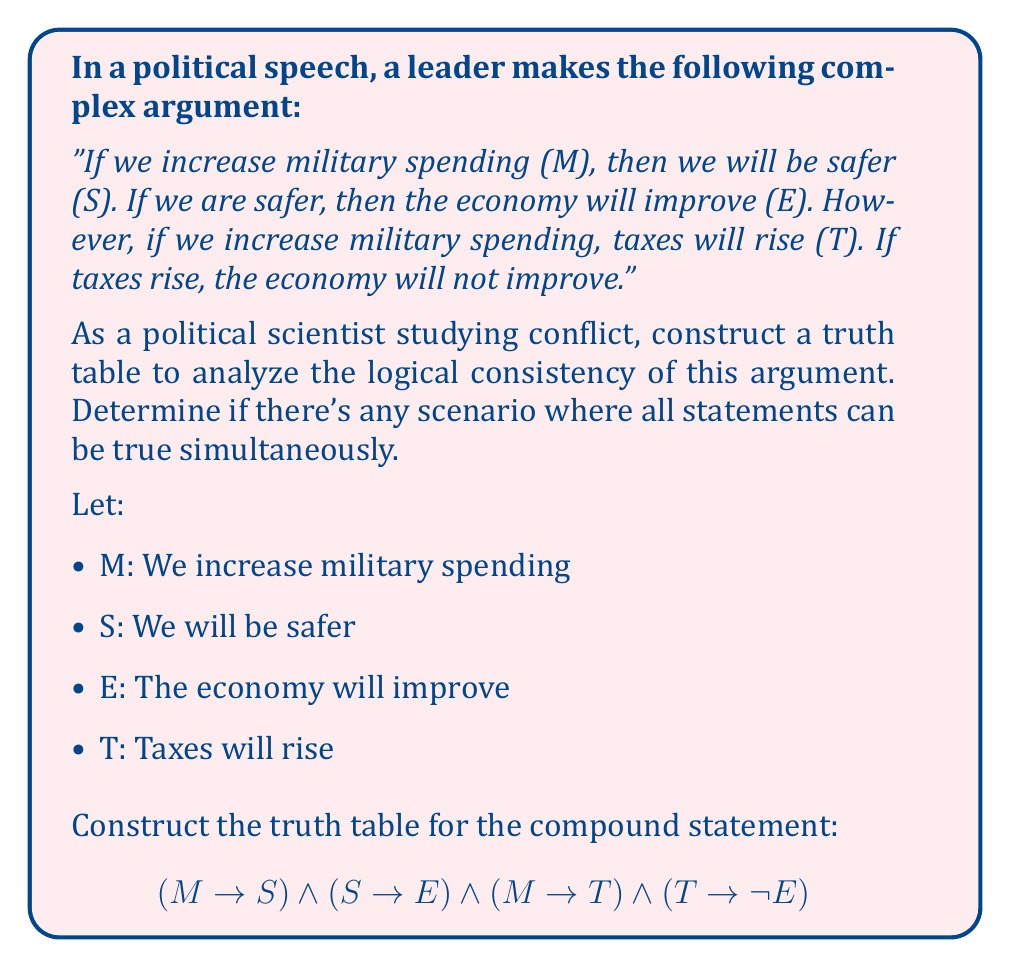Help me with this question. To analyze this argument, we'll construct a truth table for the given compound statement. We'll evaluate each component and then combine them to see if there's any row where all statements are true simultaneously.

1. First, let's list all possible combinations of truth values for M, S, T, and E:

   M | S | T | E
   ---------------
   T | T | T | T
   T | T | T | F
   T | T | F | T
   T | T | F | F
   T | F | T | T
   T | F | T | F
   T | F | F | T
   T | F | F | F
   F | T | T | T
   F | T | T | F
   F | T | F | T
   F | T | F | F
   F | F | T | T
   F | F | T | F
   F | F | F | T
   F | F | F | F

2. Now, let's evaluate each component of the compound statement:

   a) $M \rightarrow S$
   b) $S \rightarrow E$
   c) $M \rightarrow T$
   d) $T \rightarrow \lnot E$

3. Evaluate each component and the final compound statement:

   M | S | T | E | M→S | S→E | M→T | T→¬E | (M→S)∧(S→E)∧(M→T)∧(T→¬E)
   ----------------------------------------------------------------
   T | T | T | T |  T  |  T  |  T  |  F   |           F
   T | T | T | F |  T  |  F  |  T  |  T   |           F
   T | T | F | T |  T  |  T  |  F  |  T   |           F
   T | T | F | F |  T  |  F  |  F  |  T   |           F
   T | F | T | T |  F  |  T  |  T  |  F   |           F
   T | F | T | F |  F  |  T  |  T  |  T   |           F
   T | F | F | T |  F  |  T  |  F  |  T   |           F
   T | F | F | F |  F  |  T  |  F  |  T   |           F
   F | T | T | T |  T  |  T  |  T  |  F   |           F
   F | T | T | F |  T  |  F  |  T  |  T   |           F
   F | T | F | T |  T  |  T  |  T  |  T   |           T
   F | T | F | F |  T  |  F  |  T  |  T   |           F
   F | F | T | T |  T  |  T  |  T  |  F   |           F
   F | F | T | F |  T  |  T  |  T  |  T   |           T
   F | F | F | T |  T  |  T  |  T  |  T   |           T
   F | F | F | F |  T  |  T  |  T  |  T   |           T

4. Analyzing the results:
   - There are four scenarios where the compound statement is true (last column).
   - However, none of these scenarios have M (military spending increase) as true.
   - This means the argument is logically inconsistent when military spending is increased.

5. Political science interpretation:
   The leader's argument contains logical inconsistencies. It's impossible for all parts of the argument to be true simultaneously when military spending is increased. This reveals potential flaws in the reasoning or oversimplification of complex economic and security relationships.
Answer: The argument is logically inconsistent. No scenario exists where all statements are true simultaneously when military spending is increased. 